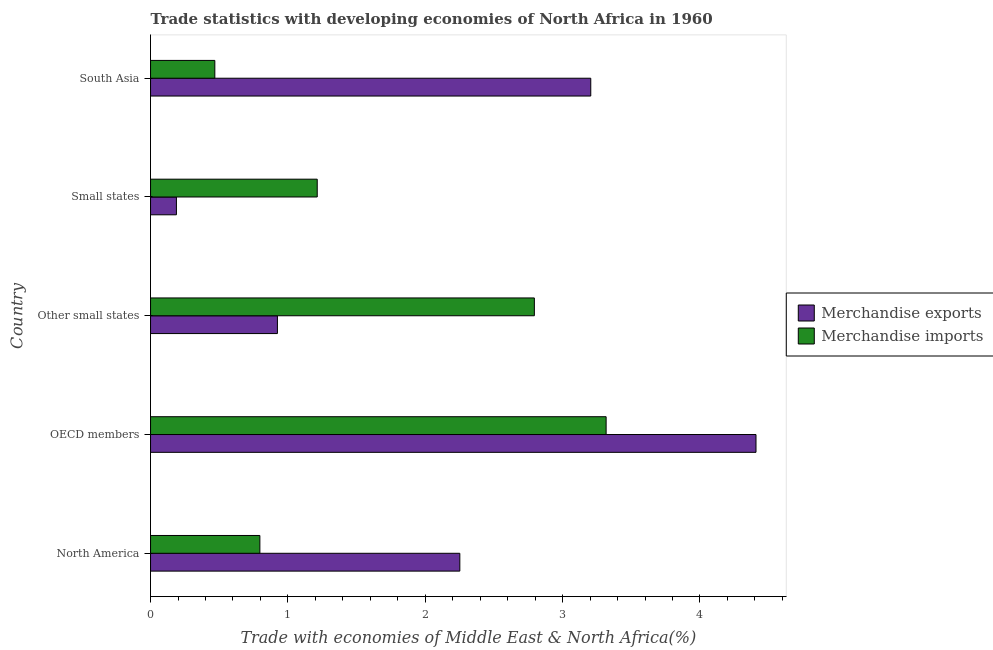How many different coloured bars are there?
Keep it short and to the point. 2. How many bars are there on the 5th tick from the bottom?
Ensure brevity in your answer.  2. What is the label of the 5th group of bars from the top?
Ensure brevity in your answer.  North America. In how many cases, is the number of bars for a given country not equal to the number of legend labels?
Ensure brevity in your answer.  0. What is the merchandise imports in Other small states?
Your answer should be compact. 2.79. Across all countries, what is the maximum merchandise imports?
Keep it short and to the point. 3.32. Across all countries, what is the minimum merchandise exports?
Give a very brief answer. 0.19. In which country was the merchandise exports maximum?
Keep it short and to the point. OECD members. In which country was the merchandise exports minimum?
Provide a short and direct response. Small states. What is the total merchandise imports in the graph?
Provide a short and direct response. 8.59. What is the difference between the merchandise imports in Other small states and that in South Asia?
Ensure brevity in your answer.  2.33. What is the difference between the merchandise imports in Small states and the merchandise exports in North America?
Give a very brief answer. -1.04. What is the average merchandise exports per country?
Offer a terse response. 2.19. What is the difference between the merchandise imports and merchandise exports in South Asia?
Your answer should be very brief. -2.74. What is the ratio of the merchandise exports in OECD members to that in Small states?
Your answer should be very brief. 23.4. Is the merchandise exports in Other small states less than that in Small states?
Provide a succinct answer. No. What is the difference between the highest and the second highest merchandise imports?
Your answer should be very brief. 0.52. What is the difference between the highest and the lowest merchandise exports?
Provide a short and direct response. 4.22. In how many countries, is the merchandise imports greater than the average merchandise imports taken over all countries?
Provide a short and direct response. 2. Is the sum of the merchandise exports in North America and Small states greater than the maximum merchandise imports across all countries?
Provide a succinct answer. No. How many bars are there?
Offer a terse response. 10. What is the difference between two consecutive major ticks on the X-axis?
Offer a terse response. 1. Are the values on the major ticks of X-axis written in scientific E-notation?
Your response must be concise. No. Does the graph contain grids?
Your response must be concise. No. How are the legend labels stacked?
Your response must be concise. Vertical. What is the title of the graph?
Offer a very short reply. Trade statistics with developing economies of North Africa in 1960. Does "Chemicals" appear as one of the legend labels in the graph?
Provide a short and direct response. No. What is the label or title of the X-axis?
Make the answer very short. Trade with economies of Middle East & North Africa(%). What is the Trade with economies of Middle East & North Africa(%) of Merchandise exports in North America?
Your answer should be very brief. 2.25. What is the Trade with economies of Middle East & North Africa(%) in Merchandise imports in North America?
Offer a terse response. 0.8. What is the Trade with economies of Middle East & North Africa(%) in Merchandise exports in OECD members?
Ensure brevity in your answer.  4.41. What is the Trade with economies of Middle East & North Africa(%) in Merchandise imports in OECD members?
Ensure brevity in your answer.  3.32. What is the Trade with economies of Middle East & North Africa(%) in Merchandise exports in Other small states?
Your answer should be compact. 0.92. What is the Trade with economies of Middle East & North Africa(%) of Merchandise imports in Other small states?
Provide a succinct answer. 2.79. What is the Trade with economies of Middle East & North Africa(%) in Merchandise exports in Small states?
Offer a terse response. 0.19. What is the Trade with economies of Middle East & North Africa(%) in Merchandise imports in Small states?
Your answer should be compact. 1.21. What is the Trade with economies of Middle East & North Africa(%) of Merchandise exports in South Asia?
Your answer should be very brief. 3.21. What is the Trade with economies of Middle East & North Africa(%) in Merchandise imports in South Asia?
Keep it short and to the point. 0.47. Across all countries, what is the maximum Trade with economies of Middle East & North Africa(%) in Merchandise exports?
Offer a terse response. 4.41. Across all countries, what is the maximum Trade with economies of Middle East & North Africa(%) in Merchandise imports?
Your answer should be very brief. 3.32. Across all countries, what is the minimum Trade with economies of Middle East & North Africa(%) in Merchandise exports?
Ensure brevity in your answer.  0.19. Across all countries, what is the minimum Trade with economies of Middle East & North Africa(%) of Merchandise imports?
Provide a succinct answer. 0.47. What is the total Trade with economies of Middle East & North Africa(%) of Merchandise exports in the graph?
Make the answer very short. 10.98. What is the total Trade with economies of Middle East & North Africa(%) in Merchandise imports in the graph?
Provide a succinct answer. 8.59. What is the difference between the Trade with economies of Middle East & North Africa(%) in Merchandise exports in North America and that in OECD members?
Provide a succinct answer. -2.16. What is the difference between the Trade with economies of Middle East & North Africa(%) in Merchandise imports in North America and that in OECD members?
Your answer should be very brief. -2.52. What is the difference between the Trade with economies of Middle East & North Africa(%) in Merchandise exports in North America and that in Other small states?
Provide a succinct answer. 1.33. What is the difference between the Trade with economies of Middle East & North Africa(%) of Merchandise imports in North America and that in Other small states?
Your answer should be very brief. -2. What is the difference between the Trade with economies of Middle East & North Africa(%) of Merchandise exports in North America and that in Small states?
Your response must be concise. 2.06. What is the difference between the Trade with economies of Middle East & North Africa(%) in Merchandise imports in North America and that in Small states?
Make the answer very short. -0.42. What is the difference between the Trade with economies of Middle East & North Africa(%) of Merchandise exports in North America and that in South Asia?
Provide a succinct answer. -0.95. What is the difference between the Trade with economies of Middle East & North Africa(%) of Merchandise imports in North America and that in South Asia?
Offer a terse response. 0.33. What is the difference between the Trade with economies of Middle East & North Africa(%) of Merchandise exports in OECD members and that in Other small states?
Keep it short and to the point. 3.48. What is the difference between the Trade with economies of Middle East & North Africa(%) in Merchandise imports in OECD members and that in Other small states?
Your answer should be very brief. 0.52. What is the difference between the Trade with economies of Middle East & North Africa(%) in Merchandise exports in OECD members and that in Small states?
Your answer should be very brief. 4.22. What is the difference between the Trade with economies of Middle East & North Africa(%) of Merchandise imports in OECD members and that in Small states?
Your response must be concise. 2.1. What is the difference between the Trade with economies of Middle East & North Africa(%) in Merchandise exports in OECD members and that in South Asia?
Make the answer very short. 1.2. What is the difference between the Trade with economies of Middle East & North Africa(%) in Merchandise imports in OECD members and that in South Asia?
Your answer should be very brief. 2.85. What is the difference between the Trade with economies of Middle East & North Africa(%) in Merchandise exports in Other small states and that in Small states?
Provide a short and direct response. 0.74. What is the difference between the Trade with economies of Middle East & North Africa(%) in Merchandise imports in Other small states and that in Small states?
Make the answer very short. 1.58. What is the difference between the Trade with economies of Middle East & North Africa(%) of Merchandise exports in Other small states and that in South Asia?
Your response must be concise. -2.28. What is the difference between the Trade with economies of Middle East & North Africa(%) of Merchandise imports in Other small states and that in South Asia?
Keep it short and to the point. 2.33. What is the difference between the Trade with economies of Middle East & North Africa(%) of Merchandise exports in Small states and that in South Asia?
Your answer should be very brief. -3.02. What is the difference between the Trade with economies of Middle East & North Africa(%) of Merchandise imports in Small states and that in South Asia?
Your response must be concise. 0.75. What is the difference between the Trade with economies of Middle East & North Africa(%) in Merchandise exports in North America and the Trade with economies of Middle East & North Africa(%) in Merchandise imports in OECD members?
Ensure brevity in your answer.  -1.07. What is the difference between the Trade with economies of Middle East & North Africa(%) of Merchandise exports in North America and the Trade with economies of Middle East & North Africa(%) of Merchandise imports in Other small states?
Provide a short and direct response. -0.54. What is the difference between the Trade with economies of Middle East & North Africa(%) of Merchandise exports in North America and the Trade with economies of Middle East & North Africa(%) of Merchandise imports in Small states?
Your answer should be very brief. 1.04. What is the difference between the Trade with economies of Middle East & North Africa(%) of Merchandise exports in North America and the Trade with economies of Middle East & North Africa(%) of Merchandise imports in South Asia?
Provide a short and direct response. 1.78. What is the difference between the Trade with economies of Middle East & North Africa(%) in Merchandise exports in OECD members and the Trade with economies of Middle East & North Africa(%) in Merchandise imports in Other small states?
Ensure brevity in your answer.  1.61. What is the difference between the Trade with economies of Middle East & North Africa(%) in Merchandise exports in OECD members and the Trade with economies of Middle East & North Africa(%) in Merchandise imports in Small states?
Offer a terse response. 3.19. What is the difference between the Trade with economies of Middle East & North Africa(%) of Merchandise exports in OECD members and the Trade with economies of Middle East & North Africa(%) of Merchandise imports in South Asia?
Give a very brief answer. 3.94. What is the difference between the Trade with economies of Middle East & North Africa(%) of Merchandise exports in Other small states and the Trade with economies of Middle East & North Africa(%) of Merchandise imports in Small states?
Offer a very short reply. -0.29. What is the difference between the Trade with economies of Middle East & North Africa(%) in Merchandise exports in Other small states and the Trade with economies of Middle East & North Africa(%) in Merchandise imports in South Asia?
Keep it short and to the point. 0.46. What is the difference between the Trade with economies of Middle East & North Africa(%) in Merchandise exports in Small states and the Trade with economies of Middle East & North Africa(%) in Merchandise imports in South Asia?
Your answer should be very brief. -0.28. What is the average Trade with economies of Middle East & North Africa(%) of Merchandise exports per country?
Ensure brevity in your answer.  2.2. What is the average Trade with economies of Middle East & North Africa(%) in Merchandise imports per country?
Your answer should be very brief. 1.72. What is the difference between the Trade with economies of Middle East & North Africa(%) of Merchandise exports and Trade with economies of Middle East & North Africa(%) of Merchandise imports in North America?
Ensure brevity in your answer.  1.46. What is the difference between the Trade with economies of Middle East & North Africa(%) of Merchandise exports and Trade with economies of Middle East & North Africa(%) of Merchandise imports in OECD members?
Ensure brevity in your answer.  1.09. What is the difference between the Trade with economies of Middle East & North Africa(%) in Merchandise exports and Trade with economies of Middle East & North Africa(%) in Merchandise imports in Other small states?
Your answer should be very brief. -1.87. What is the difference between the Trade with economies of Middle East & North Africa(%) in Merchandise exports and Trade with economies of Middle East & North Africa(%) in Merchandise imports in Small states?
Provide a short and direct response. -1.03. What is the difference between the Trade with economies of Middle East & North Africa(%) of Merchandise exports and Trade with economies of Middle East & North Africa(%) of Merchandise imports in South Asia?
Provide a succinct answer. 2.74. What is the ratio of the Trade with economies of Middle East & North Africa(%) in Merchandise exports in North America to that in OECD members?
Your answer should be compact. 0.51. What is the ratio of the Trade with economies of Middle East & North Africa(%) in Merchandise imports in North America to that in OECD members?
Keep it short and to the point. 0.24. What is the ratio of the Trade with economies of Middle East & North Africa(%) of Merchandise exports in North America to that in Other small states?
Your answer should be compact. 2.44. What is the ratio of the Trade with economies of Middle East & North Africa(%) of Merchandise imports in North America to that in Other small states?
Your response must be concise. 0.28. What is the ratio of the Trade with economies of Middle East & North Africa(%) in Merchandise exports in North America to that in Small states?
Your answer should be very brief. 11.95. What is the ratio of the Trade with economies of Middle East & North Africa(%) in Merchandise imports in North America to that in Small states?
Provide a succinct answer. 0.66. What is the ratio of the Trade with economies of Middle East & North Africa(%) of Merchandise exports in North America to that in South Asia?
Give a very brief answer. 0.7. What is the ratio of the Trade with economies of Middle East & North Africa(%) in Merchandise imports in North America to that in South Asia?
Provide a succinct answer. 1.7. What is the ratio of the Trade with economies of Middle East & North Africa(%) of Merchandise exports in OECD members to that in Other small states?
Your answer should be very brief. 4.77. What is the ratio of the Trade with economies of Middle East & North Africa(%) of Merchandise imports in OECD members to that in Other small states?
Offer a terse response. 1.19. What is the ratio of the Trade with economies of Middle East & North Africa(%) in Merchandise exports in OECD members to that in Small states?
Offer a terse response. 23.4. What is the ratio of the Trade with economies of Middle East & North Africa(%) in Merchandise imports in OECD members to that in Small states?
Keep it short and to the point. 2.73. What is the ratio of the Trade with economies of Middle East & North Africa(%) in Merchandise exports in OECD members to that in South Asia?
Your answer should be compact. 1.38. What is the ratio of the Trade with economies of Middle East & North Africa(%) in Merchandise imports in OECD members to that in South Asia?
Ensure brevity in your answer.  7.09. What is the ratio of the Trade with economies of Middle East & North Africa(%) of Merchandise exports in Other small states to that in Small states?
Your response must be concise. 4.9. What is the ratio of the Trade with economies of Middle East & North Africa(%) of Merchandise imports in Other small states to that in Small states?
Make the answer very short. 2.3. What is the ratio of the Trade with economies of Middle East & North Africa(%) of Merchandise exports in Other small states to that in South Asia?
Ensure brevity in your answer.  0.29. What is the ratio of the Trade with economies of Middle East & North Africa(%) of Merchandise imports in Other small states to that in South Asia?
Make the answer very short. 5.97. What is the ratio of the Trade with economies of Middle East & North Africa(%) in Merchandise exports in Small states to that in South Asia?
Give a very brief answer. 0.06. What is the ratio of the Trade with economies of Middle East & North Africa(%) of Merchandise imports in Small states to that in South Asia?
Ensure brevity in your answer.  2.59. What is the difference between the highest and the second highest Trade with economies of Middle East & North Africa(%) in Merchandise exports?
Give a very brief answer. 1.2. What is the difference between the highest and the second highest Trade with economies of Middle East & North Africa(%) of Merchandise imports?
Your answer should be very brief. 0.52. What is the difference between the highest and the lowest Trade with economies of Middle East & North Africa(%) in Merchandise exports?
Make the answer very short. 4.22. What is the difference between the highest and the lowest Trade with economies of Middle East & North Africa(%) in Merchandise imports?
Make the answer very short. 2.85. 